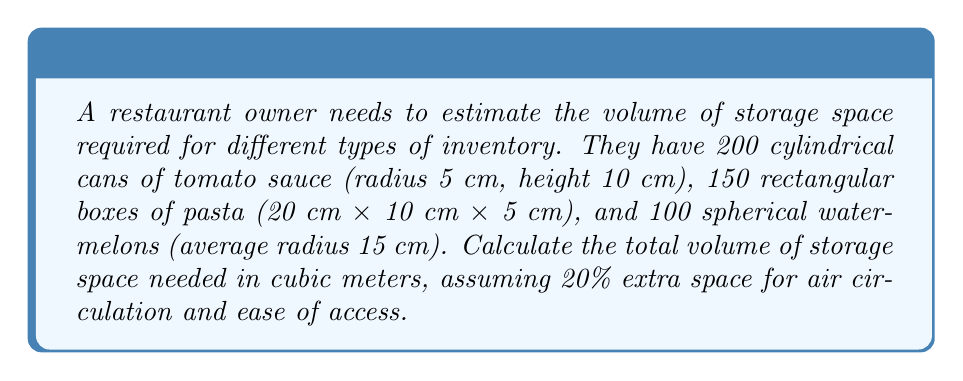Help me with this question. Let's calculate the volume for each type of inventory:

1. Cylindrical cans of tomato sauce:
   Volume of one can: $V_{can} = \pi r^2 h = \pi \cdot (0.05 \text{ m})^2 \cdot 0.10 \text{ m} = 7.85 \times 10^{-4} \text{ m}^3$
   Total volume for 200 cans: $V_{cans} = 200 \cdot 7.85 \times 10^{-4} = 0.157 \text{ m}^3$

2. Rectangular boxes of pasta:
   Volume of one box: $V_{box} = l \cdot w \cdot h = 0.20 \text{ m} \cdot 0.10 \text{ m} \cdot 0.05 \text{ m} = 1 \times 10^{-3} \text{ m}^3$
   Total volume for 150 boxes: $V_{boxes} = 150 \cdot 1 \times 10^{-3} = 0.15 \text{ m}^3$

3. Spherical watermelons:
   Volume of one watermelon: $V_{melon} = \frac{4}{3}\pi r^3 = \frac{4}{3}\pi \cdot (0.15 \text{ m})^3 = 0.014137 \text{ m}^3$
   Total volume for 100 watermelons: $V_{melons} = 100 \cdot 0.014137 = 1.4137 \text{ m}^3$

Sum of all inventory volumes:
$V_{total} = V_{cans} + V_{boxes} + V_{melons} = 0.157 + 0.15 + 1.4137 = 1.7207 \text{ m}^3$

Adding 20% extra space:
$V_{storage} = V_{total} \cdot 1.2 = 1.7207 \cdot 1.2 = 2.06484 \text{ m}^3$
Answer: $2.06 \text{ m}^3$ 